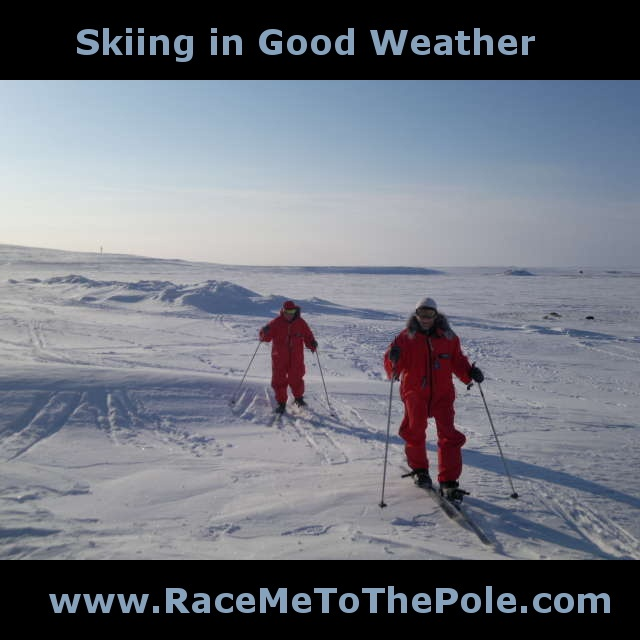Describe the objects in this image and their specific colors. I can see people in black, maroon, and gray tones, people in black, maroon, and gray tones, skis in black, gray, and darkblue tones, skis in black and gray tones, and people in black, lightgray, and darkgray tones in this image. 